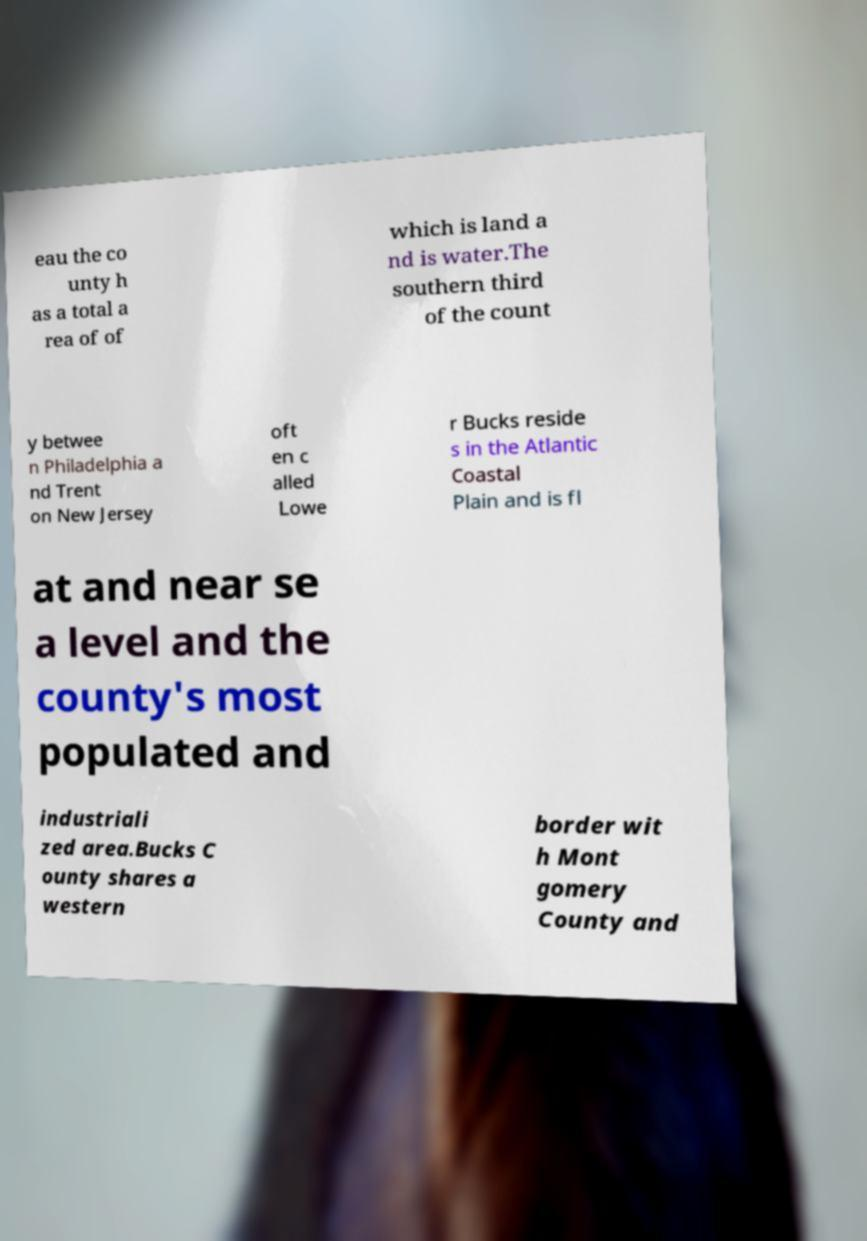Could you assist in decoding the text presented in this image and type it out clearly? eau the co unty h as a total a rea of of which is land a nd is water.The southern third of the count y betwee n Philadelphia a nd Trent on New Jersey oft en c alled Lowe r Bucks reside s in the Atlantic Coastal Plain and is fl at and near se a level and the county's most populated and industriali zed area.Bucks C ounty shares a western border wit h Mont gomery County and 